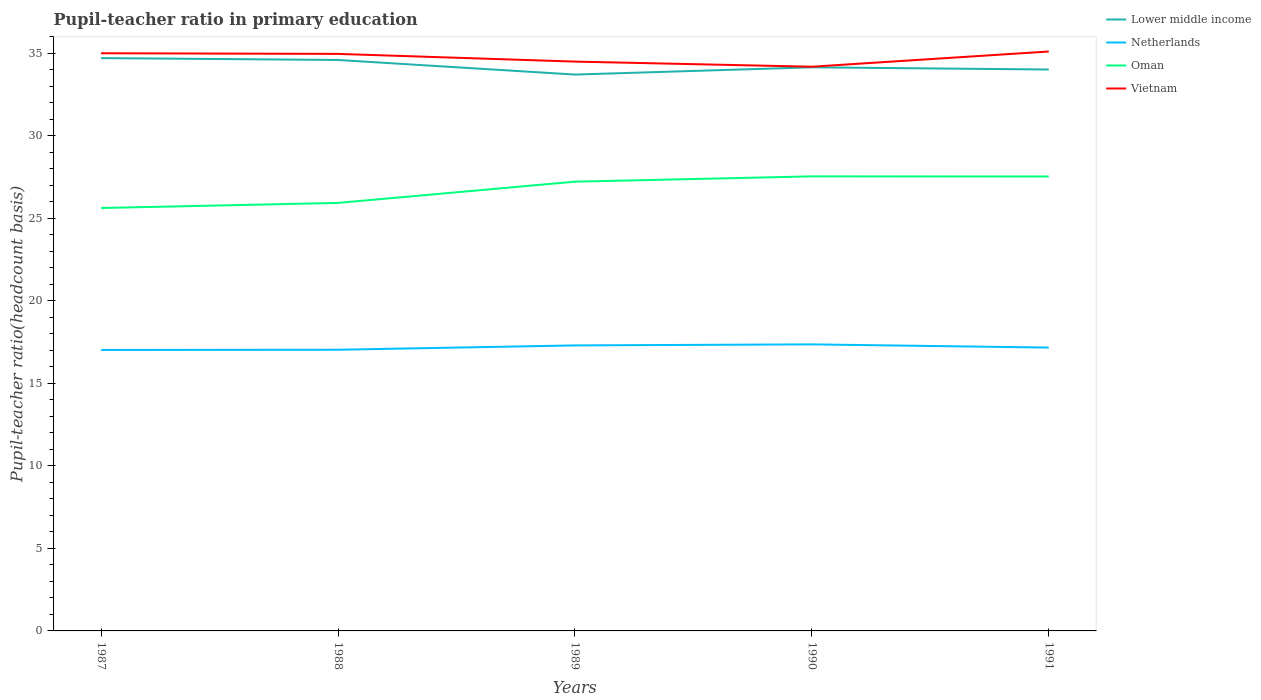Does the line corresponding to Netherlands intersect with the line corresponding to Vietnam?
Your answer should be very brief. No. Across all years, what is the maximum pupil-teacher ratio in primary education in Netherlands?
Ensure brevity in your answer.  17.02. In which year was the pupil-teacher ratio in primary education in Netherlands maximum?
Offer a terse response. 1987. What is the total pupil-teacher ratio in primary education in Netherlands in the graph?
Your answer should be very brief. 0.19. What is the difference between the highest and the second highest pupil-teacher ratio in primary education in Netherlands?
Give a very brief answer. 0.34. How many years are there in the graph?
Offer a terse response. 5. What is the difference between two consecutive major ticks on the Y-axis?
Provide a short and direct response. 5. How are the legend labels stacked?
Make the answer very short. Vertical. What is the title of the graph?
Your answer should be compact. Pupil-teacher ratio in primary education. Does "Zambia" appear as one of the legend labels in the graph?
Make the answer very short. No. What is the label or title of the Y-axis?
Give a very brief answer. Pupil-teacher ratio(headcount basis). What is the Pupil-teacher ratio(headcount basis) in Lower middle income in 1987?
Make the answer very short. 34.71. What is the Pupil-teacher ratio(headcount basis) of Netherlands in 1987?
Your answer should be very brief. 17.02. What is the Pupil-teacher ratio(headcount basis) of Oman in 1987?
Your answer should be compact. 25.63. What is the Pupil-teacher ratio(headcount basis) in Vietnam in 1987?
Your answer should be compact. 35. What is the Pupil-teacher ratio(headcount basis) in Lower middle income in 1988?
Offer a terse response. 34.6. What is the Pupil-teacher ratio(headcount basis) of Netherlands in 1988?
Your answer should be very brief. 17.04. What is the Pupil-teacher ratio(headcount basis) of Oman in 1988?
Your answer should be very brief. 25.93. What is the Pupil-teacher ratio(headcount basis) of Vietnam in 1988?
Ensure brevity in your answer.  34.96. What is the Pupil-teacher ratio(headcount basis) in Lower middle income in 1989?
Keep it short and to the point. 33.71. What is the Pupil-teacher ratio(headcount basis) of Netherlands in 1989?
Keep it short and to the point. 17.3. What is the Pupil-teacher ratio(headcount basis) in Oman in 1989?
Give a very brief answer. 27.22. What is the Pupil-teacher ratio(headcount basis) in Vietnam in 1989?
Ensure brevity in your answer.  34.5. What is the Pupil-teacher ratio(headcount basis) of Lower middle income in 1990?
Make the answer very short. 34.15. What is the Pupil-teacher ratio(headcount basis) of Netherlands in 1990?
Ensure brevity in your answer.  17.36. What is the Pupil-teacher ratio(headcount basis) in Oman in 1990?
Ensure brevity in your answer.  27.54. What is the Pupil-teacher ratio(headcount basis) in Vietnam in 1990?
Ensure brevity in your answer.  34.19. What is the Pupil-teacher ratio(headcount basis) of Lower middle income in 1991?
Make the answer very short. 34.02. What is the Pupil-teacher ratio(headcount basis) of Netherlands in 1991?
Ensure brevity in your answer.  17.17. What is the Pupil-teacher ratio(headcount basis) in Oman in 1991?
Your answer should be very brief. 27.54. What is the Pupil-teacher ratio(headcount basis) in Vietnam in 1991?
Give a very brief answer. 35.11. Across all years, what is the maximum Pupil-teacher ratio(headcount basis) in Lower middle income?
Your response must be concise. 34.71. Across all years, what is the maximum Pupil-teacher ratio(headcount basis) in Netherlands?
Provide a short and direct response. 17.36. Across all years, what is the maximum Pupil-teacher ratio(headcount basis) of Oman?
Ensure brevity in your answer.  27.54. Across all years, what is the maximum Pupil-teacher ratio(headcount basis) of Vietnam?
Provide a succinct answer. 35.11. Across all years, what is the minimum Pupil-teacher ratio(headcount basis) of Lower middle income?
Your answer should be compact. 33.71. Across all years, what is the minimum Pupil-teacher ratio(headcount basis) of Netherlands?
Keep it short and to the point. 17.02. Across all years, what is the minimum Pupil-teacher ratio(headcount basis) in Oman?
Make the answer very short. 25.63. Across all years, what is the minimum Pupil-teacher ratio(headcount basis) of Vietnam?
Offer a very short reply. 34.19. What is the total Pupil-teacher ratio(headcount basis) in Lower middle income in the graph?
Your answer should be compact. 171.19. What is the total Pupil-teacher ratio(headcount basis) of Netherlands in the graph?
Give a very brief answer. 85.9. What is the total Pupil-teacher ratio(headcount basis) of Oman in the graph?
Your answer should be compact. 133.86. What is the total Pupil-teacher ratio(headcount basis) in Vietnam in the graph?
Offer a very short reply. 173.77. What is the difference between the Pupil-teacher ratio(headcount basis) of Lower middle income in 1987 and that in 1988?
Your answer should be compact. 0.11. What is the difference between the Pupil-teacher ratio(headcount basis) of Netherlands in 1987 and that in 1988?
Keep it short and to the point. -0.01. What is the difference between the Pupil-teacher ratio(headcount basis) in Oman in 1987 and that in 1988?
Your answer should be compact. -0.31. What is the difference between the Pupil-teacher ratio(headcount basis) of Vietnam in 1987 and that in 1988?
Your response must be concise. 0.04. What is the difference between the Pupil-teacher ratio(headcount basis) in Netherlands in 1987 and that in 1989?
Provide a short and direct response. -0.28. What is the difference between the Pupil-teacher ratio(headcount basis) in Oman in 1987 and that in 1989?
Make the answer very short. -1.6. What is the difference between the Pupil-teacher ratio(headcount basis) of Vietnam in 1987 and that in 1989?
Your answer should be very brief. 0.51. What is the difference between the Pupil-teacher ratio(headcount basis) in Lower middle income in 1987 and that in 1990?
Give a very brief answer. 0.56. What is the difference between the Pupil-teacher ratio(headcount basis) in Netherlands in 1987 and that in 1990?
Offer a terse response. -0.34. What is the difference between the Pupil-teacher ratio(headcount basis) in Oman in 1987 and that in 1990?
Provide a short and direct response. -1.92. What is the difference between the Pupil-teacher ratio(headcount basis) of Vietnam in 1987 and that in 1990?
Make the answer very short. 0.82. What is the difference between the Pupil-teacher ratio(headcount basis) in Lower middle income in 1987 and that in 1991?
Keep it short and to the point. 0.69. What is the difference between the Pupil-teacher ratio(headcount basis) in Netherlands in 1987 and that in 1991?
Provide a short and direct response. -0.14. What is the difference between the Pupil-teacher ratio(headcount basis) of Oman in 1987 and that in 1991?
Make the answer very short. -1.91. What is the difference between the Pupil-teacher ratio(headcount basis) in Vietnam in 1987 and that in 1991?
Offer a very short reply. -0.11. What is the difference between the Pupil-teacher ratio(headcount basis) of Lower middle income in 1988 and that in 1989?
Ensure brevity in your answer.  0.88. What is the difference between the Pupil-teacher ratio(headcount basis) of Netherlands in 1988 and that in 1989?
Ensure brevity in your answer.  -0.26. What is the difference between the Pupil-teacher ratio(headcount basis) in Oman in 1988 and that in 1989?
Your answer should be compact. -1.29. What is the difference between the Pupil-teacher ratio(headcount basis) in Vietnam in 1988 and that in 1989?
Give a very brief answer. 0.47. What is the difference between the Pupil-teacher ratio(headcount basis) in Lower middle income in 1988 and that in 1990?
Ensure brevity in your answer.  0.44. What is the difference between the Pupil-teacher ratio(headcount basis) of Netherlands in 1988 and that in 1990?
Offer a very short reply. -0.32. What is the difference between the Pupil-teacher ratio(headcount basis) of Oman in 1988 and that in 1990?
Your answer should be very brief. -1.61. What is the difference between the Pupil-teacher ratio(headcount basis) in Vietnam in 1988 and that in 1990?
Offer a very short reply. 0.78. What is the difference between the Pupil-teacher ratio(headcount basis) in Lower middle income in 1988 and that in 1991?
Provide a short and direct response. 0.58. What is the difference between the Pupil-teacher ratio(headcount basis) in Netherlands in 1988 and that in 1991?
Your answer should be compact. -0.13. What is the difference between the Pupil-teacher ratio(headcount basis) in Oman in 1988 and that in 1991?
Your answer should be very brief. -1.6. What is the difference between the Pupil-teacher ratio(headcount basis) in Vietnam in 1988 and that in 1991?
Your response must be concise. -0.15. What is the difference between the Pupil-teacher ratio(headcount basis) in Lower middle income in 1989 and that in 1990?
Provide a succinct answer. -0.44. What is the difference between the Pupil-teacher ratio(headcount basis) in Netherlands in 1989 and that in 1990?
Give a very brief answer. -0.06. What is the difference between the Pupil-teacher ratio(headcount basis) of Oman in 1989 and that in 1990?
Make the answer very short. -0.32. What is the difference between the Pupil-teacher ratio(headcount basis) of Vietnam in 1989 and that in 1990?
Give a very brief answer. 0.31. What is the difference between the Pupil-teacher ratio(headcount basis) in Lower middle income in 1989 and that in 1991?
Offer a very short reply. -0.31. What is the difference between the Pupil-teacher ratio(headcount basis) of Netherlands in 1989 and that in 1991?
Your answer should be compact. 0.13. What is the difference between the Pupil-teacher ratio(headcount basis) of Oman in 1989 and that in 1991?
Your response must be concise. -0.31. What is the difference between the Pupil-teacher ratio(headcount basis) in Vietnam in 1989 and that in 1991?
Provide a succinct answer. -0.61. What is the difference between the Pupil-teacher ratio(headcount basis) in Lower middle income in 1990 and that in 1991?
Make the answer very short. 0.13. What is the difference between the Pupil-teacher ratio(headcount basis) in Netherlands in 1990 and that in 1991?
Offer a very short reply. 0.19. What is the difference between the Pupil-teacher ratio(headcount basis) of Oman in 1990 and that in 1991?
Offer a terse response. 0.01. What is the difference between the Pupil-teacher ratio(headcount basis) in Vietnam in 1990 and that in 1991?
Your response must be concise. -0.92. What is the difference between the Pupil-teacher ratio(headcount basis) of Lower middle income in 1987 and the Pupil-teacher ratio(headcount basis) of Netherlands in 1988?
Keep it short and to the point. 17.67. What is the difference between the Pupil-teacher ratio(headcount basis) of Lower middle income in 1987 and the Pupil-teacher ratio(headcount basis) of Oman in 1988?
Provide a short and direct response. 8.78. What is the difference between the Pupil-teacher ratio(headcount basis) of Lower middle income in 1987 and the Pupil-teacher ratio(headcount basis) of Vietnam in 1988?
Your response must be concise. -0.25. What is the difference between the Pupil-teacher ratio(headcount basis) of Netherlands in 1987 and the Pupil-teacher ratio(headcount basis) of Oman in 1988?
Make the answer very short. -8.91. What is the difference between the Pupil-teacher ratio(headcount basis) in Netherlands in 1987 and the Pupil-teacher ratio(headcount basis) in Vietnam in 1988?
Make the answer very short. -17.94. What is the difference between the Pupil-teacher ratio(headcount basis) in Oman in 1987 and the Pupil-teacher ratio(headcount basis) in Vietnam in 1988?
Make the answer very short. -9.34. What is the difference between the Pupil-teacher ratio(headcount basis) in Lower middle income in 1987 and the Pupil-teacher ratio(headcount basis) in Netherlands in 1989?
Provide a short and direct response. 17.41. What is the difference between the Pupil-teacher ratio(headcount basis) of Lower middle income in 1987 and the Pupil-teacher ratio(headcount basis) of Oman in 1989?
Make the answer very short. 7.49. What is the difference between the Pupil-teacher ratio(headcount basis) in Lower middle income in 1987 and the Pupil-teacher ratio(headcount basis) in Vietnam in 1989?
Ensure brevity in your answer.  0.21. What is the difference between the Pupil-teacher ratio(headcount basis) of Netherlands in 1987 and the Pupil-teacher ratio(headcount basis) of Oman in 1989?
Your response must be concise. -10.2. What is the difference between the Pupil-teacher ratio(headcount basis) in Netherlands in 1987 and the Pupil-teacher ratio(headcount basis) in Vietnam in 1989?
Ensure brevity in your answer.  -17.47. What is the difference between the Pupil-teacher ratio(headcount basis) of Oman in 1987 and the Pupil-teacher ratio(headcount basis) of Vietnam in 1989?
Ensure brevity in your answer.  -8.87. What is the difference between the Pupil-teacher ratio(headcount basis) of Lower middle income in 1987 and the Pupil-teacher ratio(headcount basis) of Netherlands in 1990?
Your response must be concise. 17.35. What is the difference between the Pupil-teacher ratio(headcount basis) of Lower middle income in 1987 and the Pupil-teacher ratio(headcount basis) of Oman in 1990?
Your answer should be compact. 7.17. What is the difference between the Pupil-teacher ratio(headcount basis) of Lower middle income in 1987 and the Pupil-teacher ratio(headcount basis) of Vietnam in 1990?
Provide a succinct answer. 0.52. What is the difference between the Pupil-teacher ratio(headcount basis) of Netherlands in 1987 and the Pupil-teacher ratio(headcount basis) of Oman in 1990?
Your response must be concise. -10.52. What is the difference between the Pupil-teacher ratio(headcount basis) in Netherlands in 1987 and the Pupil-teacher ratio(headcount basis) in Vietnam in 1990?
Provide a short and direct response. -17.16. What is the difference between the Pupil-teacher ratio(headcount basis) of Oman in 1987 and the Pupil-teacher ratio(headcount basis) of Vietnam in 1990?
Provide a succinct answer. -8.56. What is the difference between the Pupil-teacher ratio(headcount basis) in Lower middle income in 1987 and the Pupil-teacher ratio(headcount basis) in Netherlands in 1991?
Keep it short and to the point. 17.54. What is the difference between the Pupil-teacher ratio(headcount basis) in Lower middle income in 1987 and the Pupil-teacher ratio(headcount basis) in Oman in 1991?
Provide a succinct answer. 7.18. What is the difference between the Pupil-teacher ratio(headcount basis) in Lower middle income in 1987 and the Pupil-teacher ratio(headcount basis) in Vietnam in 1991?
Keep it short and to the point. -0.4. What is the difference between the Pupil-teacher ratio(headcount basis) of Netherlands in 1987 and the Pupil-teacher ratio(headcount basis) of Oman in 1991?
Offer a terse response. -10.51. What is the difference between the Pupil-teacher ratio(headcount basis) of Netherlands in 1987 and the Pupil-teacher ratio(headcount basis) of Vietnam in 1991?
Keep it short and to the point. -18.09. What is the difference between the Pupil-teacher ratio(headcount basis) in Oman in 1987 and the Pupil-teacher ratio(headcount basis) in Vietnam in 1991?
Provide a succinct answer. -9.48. What is the difference between the Pupil-teacher ratio(headcount basis) in Lower middle income in 1988 and the Pupil-teacher ratio(headcount basis) in Netherlands in 1989?
Ensure brevity in your answer.  17.3. What is the difference between the Pupil-teacher ratio(headcount basis) of Lower middle income in 1988 and the Pupil-teacher ratio(headcount basis) of Oman in 1989?
Offer a terse response. 7.37. What is the difference between the Pupil-teacher ratio(headcount basis) in Lower middle income in 1988 and the Pupil-teacher ratio(headcount basis) in Vietnam in 1989?
Keep it short and to the point. 0.1. What is the difference between the Pupil-teacher ratio(headcount basis) of Netherlands in 1988 and the Pupil-teacher ratio(headcount basis) of Oman in 1989?
Give a very brief answer. -10.18. What is the difference between the Pupil-teacher ratio(headcount basis) of Netherlands in 1988 and the Pupil-teacher ratio(headcount basis) of Vietnam in 1989?
Ensure brevity in your answer.  -17.46. What is the difference between the Pupil-teacher ratio(headcount basis) of Oman in 1988 and the Pupil-teacher ratio(headcount basis) of Vietnam in 1989?
Keep it short and to the point. -8.56. What is the difference between the Pupil-teacher ratio(headcount basis) in Lower middle income in 1988 and the Pupil-teacher ratio(headcount basis) in Netherlands in 1990?
Provide a short and direct response. 17.23. What is the difference between the Pupil-teacher ratio(headcount basis) in Lower middle income in 1988 and the Pupil-teacher ratio(headcount basis) in Oman in 1990?
Your answer should be compact. 7.05. What is the difference between the Pupil-teacher ratio(headcount basis) in Lower middle income in 1988 and the Pupil-teacher ratio(headcount basis) in Vietnam in 1990?
Provide a succinct answer. 0.41. What is the difference between the Pupil-teacher ratio(headcount basis) of Netherlands in 1988 and the Pupil-teacher ratio(headcount basis) of Oman in 1990?
Offer a terse response. -10.51. What is the difference between the Pupil-teacher ratio(headcount basis) of Netherlands in 1988 and the Pupil-teacher ratio(headcount basis) of Vietnam in 1990?
Offer a very short reply. -17.15. What is the difference between the Pupil-teacher ratio(headcount basis) in Oman in 1988 and the Pupil-teacher ratio(headcount basis) in Vietnam in 1990?
Give a very brief answer. -8.25. What is the difference between the Pupil-teacher ratio(headcount basis) of Lower middle income in 1988 and the Pupil-teacher ratio(headcount basis) of Netherlands in 1991?
Make the answer very short. 17.43. What is the difference between the Pupil-teacher ratio(headcount basis) in Lower middle income in 1988 and the Pupil-teacher ratio(headcount basis) in Oman in 1991?
Provide a succinct answer. 7.06. What is the difference between the Pupil-teacher ratio(headcount basis) of Lower middle income in 1988 and the Pupil-teacher ratio(headcount basis) of Vietnam in 1991?
Keep it short and to the point. -0.51. What is the difference between the Pupil-teacher ratio(headcount basis) of Netherlands in 1988 and the Pupil-teacher ratio(headcount basis) of Oman in 1991?
Give a very brief answer. -10.5. What is the difference between the Pupil-teacher ratio(headcount basis) in Netherlands in 1988 and the Pupil-teacher ratio(headcount basis) in Vietnam in 1991?
Provide a short and direct response. -18.07. What is the difference between the Pupil-teacher ratio(headcount basis) of Oman in 1988 and the Pupil-teacher ratio(headcount basis) of Vietnam in 1991?
Provide a succinct answer. -9.18. What is the difference between the Pupil-teacher ratio(headcount basis) of Lower middle income in 1989 and the Pupil-teacher ratio(headcount basis) of Netherlands in 1990?
Your response must be concise. 16.35. What is the difference between the Pupil-teacher ratio(headcount basis) in Lower middle income in 1989 and the Pupil-teacher ratio(headcount basis) in Oman in 1990?
Your answer should be compact. 6.17. What is the difference between the Pupil-teacher ratio(headcount basis) of Lower middle income in 1989 and the Pupil-teacher ratio(headcount basis) of Vietnam in 1990?
Provide a succinct answer. -0.48. What is the difference between the Pupil-teacher ratio(headcount basis) in Netherlands in 1989 and the Pupil-teacher ratio(headcount basis) in Oman in 1990?
Provide a succinct answer. -10.24. What is the difference between the Pupil-teacher ratio(headcount basis) of Netherlands in 1989 and the Pupil-teacher ratio(headcount basis) of Vietnam in 1990?
Your answer should be compact. -16.89. What is the difference between the Pupil-teacher ratio(headcount basis) in Oman in 1989 and the Pupil-teacher ratio(headcount basis) in Vietnam in 1990?
Keep it short and to the point. -6.97. What is the difference between the Pupil-teacher ratio(headcount basis) in Lower middle income in 1989 and the Pupil-teacher ratio(headcount basis) in Netherlands in 1991?
Offer a very short reply. 16.54. What is the difference between the Pupil-teacher ratio(headcount basis) in Lower middle income in 1989 and the Pupil-teacher ratio(headcount basis) in Oman in 1991?
Offer a very short reply. 6.18. What is the difference between the Pupil-teacher ratio(headcount basis) of Lower middle income in 1989 and the Pupil-teacher ratio(headcount basis) of Vietnam in 1991?
Offer a terse response. -1.4. What is the difference between the Pupil-teacher ratio(headcount basis) of Netherlands in 1989 and the Pupil-teacher ratio(headcount basis) of Oman in 1991?
Give a very brief answer. -10.23. What is the difference between the Pupil-teacher ratio(headcount basis) of Netherlands in 1989 and the Pupil-teacher ratio(headcount basis) of Vietnam in 1991?
Your answer should be compact. -17.81. What is the difference between the Pupil-teacher ratio(headcount basis) in Oman in 1989 and the Pupil-teacher ratio(headcount basis) in Vietnam in 1991?
Offer a terse response. -7.89. What is the difference between the Pupil-teacher ratio(headcount basis) in Lower middle income in 1990 and the Pupil-teacher ratio(headcount basis) in Netherlands in 1991?
Provide a succinct answer. 16.98. What is the difference between the Pupil-teacher ratio(headcount basis) in Lower middle income in 1990 and the Pupil-teacher ratio(headcount basis) in Oman in 1991?
Give a very brief answer. 6.62. What is the difference between the Pupil-teacher ratio(headcount basis) of Lower middle income in 1990 and the Pupil-teacher ratio(headcount basis) of Vietnam in 1991?
Offer a very short reply. -0.96. What is the difference between the Pupil-teacher ratio(headcount basis) in Netherlands in 1990 and the Pupil-teacher ratio(headcount basis) in Oman in 1991?
Provide a succinct answer. -10.17. What is the difference between the Pupil-teacher ratio(headcount basis) in Netherlands in 1990 and the Pupil-teacher ratio(headcount basis) in Vietnam in 1991?
Provide a succinct answer. -17.75. What is the difference between the Pupil-teacher ratio(headcount basis) in Oman in 1990 and the Pupil-teacher ratio(headcount basis) in Vietnam in 1991?
Ensure brevity in your answer.  -7.57. What is the average Pupil-teacher ratio(headcount basis) in Lower middle income per year?
Keep it short and to the point. 34.24. What is the average Pupil-teacher ratio(headcount basis) of Netherlands per year?
Give a very brief answer. 17.18. What is the average Pupil-teacher ratio(headcount basis) in Oman per year?
Your answer should be very brief. 26.77. What is the average Pupil-teacher ratio(headcount basis) of Vietnam per year?
Your response must be concise. 34.75. In the year 1987, what is the difference between the Pupil-teacher ratio(headcount basis) of Lower middle income and Pupil-teacher ratio(headcount basis) of Netherlands?
Offer a terse response. 17.69. In the year 1987, what is the difference between the Pupil-teacher ratio(headcount basis) in Lower middle income and Pupil-teacher ratio(headcount basis) in Oman?
Your response must be concise. 9.08. In the year 1987, what is the difference between the Pupil-teacher ratio(headcount basis) in Lower middle income and Pupil-teacher ratio(headcount basis) in Vietnam?
Offer a very short reply. -0.29. In the year 1987, what is the difference between the Pupil-teacher ratio(headcount basis) of Netherlands and Pupil-teacher ratio(headcount basis) of Oman?
Provide a succinct answer. -8.6. In the year 1987, what is the difference between the Pupil-teacher ratio(headcount basis) of Netherlands and Pupil-teacher ratio(headcount basis) of Vietnam?
Your answer should be very brief. -17.98. In the year 1987, what is the difference between the Pupil-teacher ratio(headcount basis) of Oman and Pupil-teacher ratio(headcount basis) of Vietnam?
Make the answer very short. -9.38. In the year 1988, what is the difference between the Pupil-teacher ratio(headcount basis) in Lower middle income and Pupil-teacher ratio(headcount basis) in Netherlands?
Offer a terse response. 17.56. In the year 1988, what is the difference between the Pupil-teacher ratio(headcount basis) of Lower middle income and Pupil-teacher ratio(headcount basis) of Oman?
Your answer should be compact. 8.66. In the year 1988, what is the difference between the Pupil-teacher ratio(headcount basis) of Lower middle income and Pupil-teacher ratio(headcount basis) of Vietnam?
Make the answer very short. -0.37. In the year 1988, what is the difference between the Pupil-teacher ratio(headcount basis) in Netherlands and Pupil-teacher ratio(headcount basis) in Oman?
Offer a terse response. -8.9. In the year 1988, what is the difference between the Pupil-teacher ratio(headcount basis) of Netherlands and Pupil-teacher ratio(headcount basis) of Vietnam?
Offer a terse response. -17.93. In the year 1988, what is the difference between the Pupil-teacher ratio(headcount basis) in Oman and Pupil-teacher ratio(headcount basis) in Vietnam?
Keep it short and to the point. -9.03. In the year 1989, what is the difference between the Pupil-teacher ratio(headcount basis) of Lower middle income and Pupil-teacher ratio(headcount basis) of Netherlands?
Provide a succinct answer. 16.41. In the year 1989, what is the difference between the Pupil-teacher ratio(headcount basis) in Lower middle income and Pupil-teacher ratio(headcount basis) in Oman?
Keep it short and to the point. 6.49. In the year 1989, what is the difference between the Pupil-teacher ratio(headcount basis) of Lower middle income and Pupil-teacher ratio(headcount basis) of Vietnam?
Offer a terse response. -0.79. In the year 1989, what is the difference between the Pupil-teacher ratio(headcount basis) in Netherlands and Pupil-teacher ratio(headcount basis) in Oman?
Keep it short and to the point. -9.92. In the year 1989, what is the difference between the Pupil-teacher ratio(headcount basis) in Netherlands and Pupil-teacher ratio(headcount basis) in Vietnam?
Your answer should be compact. -17.2. In the year 1989, what is the difference between the Pupil-teacher ratio(headcount basis) of Oman and Pupil-teacher ratio(headcount basis) of Vietnam?
Offer a terse response. -7.28. In the year 1990, what is the difference between the Pupil-teacher ratio(headcount basis) in Lower middle income and Pupil-teacher ratio(headcount basis) in Netherlands?
Your answer should be very brief. 16.79. In the year 1990, what is the difference between the Pupil-teacher ratio(headcount basis) in Lower middle income and Pupil-teacher ratio(headcount basis) in Oman?
Provide a short and direct response. 6.61. In the year 1990, what is the difference between the Pupil-teacher ratio(headcount basis) of Lower middle income and Pupil-teacher ratio(headcount basis) of Vietnam?
Provide a succinct answer. -0.04. In the year 1990, what is the difference between the Pupil-teacher ratio(headcount basis) in Netherlands and Pupil-teacher ratio(headcount basis) in Oman?
Provide a short and direct response. -10.18. In the year 1990, what is the difference between the Pupil-teacher ratio(headcount basis) of Netherlands and Pupil-teacher ratio(headcount basis) of Vietnam?
Offer a very short reply. -16.82. In the year 1990, what is the difference between the Pupil-teacher ratio(headcount basis) in Oman and Pupil-teacher ratio(headcount basis) in Vietnam?
Offer a terse response. -6.64. In the year 1991, what is the difference between the Pupil-teacher ratio(headcount basis) of Lower middle income and Pupil-teacher ratio(headcount basis) of Netherlands?
Provide a succinct answer. 16.85. In the year 1991, what is the difference between the Pupil-teacher ratio(headcount basis) in Lower middle income and Pupil-teacher ratio(headcount basis) in Oman?
Give a very brief answer. 6.48. In the year 1991, what is the difference between the Pupil-teacher ratio(headcount basis) in Lower middle income and Pupil-teacher ratio(headcount basis) in Vietnam?
Offer a terse response. -1.09. In the year 1991, what is the difference between the Pupil-teacher ratio(headcount basis) in Netherlands and Pupil-teacher ratio(headcount basis) in Oman?
Provide a succinct answer. -10.37. In the year 1991, what is the difference between the Pupil-teacher ratio(headcount basis) of Netherlands and Pupil-teacher ratio(headcount basis) of Vietnam?
Your response must be concise. -17.94. In the year 1991, what is the difference between the Pupil-teacher ratio(headcount basis) in Oman and Pupil-teacher ratio(headcount basis) in Vietnam?
Keep it short and to the point. -7.58. What is the ratio of the Pupil-teacher ratio(headcount basis) in Vietnam in 1987 to that in 1988?
Your response must be concise. 1. What is the ratio of the Pupil-teacher ratio(headcount basis) of Lower middle income in 1987 to that in 1989?
Make the answer very short. 1.03. What is the ratio of the Pupil-teacher ratio(headcount basis) in Oman in 1987 to that in 1989?
Provide a succinct answer. 0.94. What is the ratio of the Pupil-teacher ratio(headcount basis) of Vietnam in 1987 to that in 1989?
Make the answer very short. 1.01. What is the ratio of the Pupil-teacher ratio(headcount basis) in Lower middle income in 1987 to that in 1990?
Offer a terse response. 1.02. What is the ratio of the Pupil-teacher ratio(headcount basis) in Netherlands in 1987 to that in 1990?
Provide a short and direct response. 0.98. What is the ratio of the Pupil-teacher ratio(headcount basis) of Oman in 1987 to that in 1990?
Give a very brief answer. 0.93. What is the ratio of the Pupil-teacher ratio(headcount basis) of Vietnam in 1987 to that in 1990?
Offer a very short reply. 1.02. What is the ratio of the Pupil-teacher ratio(headcount basis) of Lower middle income in 1987 to that in 1991?
Keep it short and to the point. 1.02. What is the ratio of the Pupil-teacher ratio(headcount basis) of Oman in 1987 to that in 1991?
Provide a short and direct response. 0.93. What is the ratio of the Pupil-teacher ratio(headcount basis) of Vietnam in 1987 to that in 1991?
Your answer should be very brief. 1. What is the ratio of the Pupil-teacher ratio(headcount basis) in Lower middle income in 1988 to that in 1989?
Your answer should be very brief. 1.03. What is the ratio of the Pupil-teacher ratio(headcount basis) of Netherlands in 1988 to that in 1989?
Offer a very short reply. 0.98. What is the ratio of the Pupil-teacher ratio(headcount basis) of Oman in 1988 to that in 1989?
Your answer should be very brief. 0.95. What is the ratio of the Pupil-teacher ratio(headcount basis) of Vietnam in 1988 to that in 1989?
Ensure brevity in your answer.  1.01. What is the ratio of the Pupil-teacher ratio(headcount basis) in Netherlands in 1988 to that in 1990?
Your response must be concise. 0.98. What is the ratio of the Pupil-teacher ratio(headcount basis) of Oman in 1988 to that in 1990?
Ensure brevity in your answer.  0.94. What is the ratio of the Pupil-teacher ratio(headcount basis) in Vietnam in 1988 to that in 1990?
Your answer should be very brief. 1.02. What is the ratio of the Pupil-teacher ratio(headcount basis) in Oman in 1988 to that in 1991?
Provide a short and direct response. 0.94. What is the ratio of the Pupil-teacher ratio(headcount basis) of Vietnam in 1988 to that in 1991?
Your response must be concise. 1. What is the ratio of the Pupil-teacher ratio(headcount basis) of Lower middle income in 1989 to that in 1990?
Offer a terse response. 0.99. What is the ratio of the Pupil-teacher ratio(headcount basis) in Netherlands in 1989 to that in 1990?
Your answer should be very brief. 1. What is the ratio of the Pupil-teacher ratio(headcount basis) in Oman in 1989 to that in 1990?
Offer a terse response. 0.99. What is the ratio of the Pupil-teacher ratio(headcount basis) of Vietnam in 1989 to that in 1990?
Ensure brevity in your answer.  1.01. What is the ratio of the Pupil-teacher ratio(headcount basis) in Netherlands in 1989 to that in 1991?
Your response must be concise. 1.01. What is the ratio of the Pupil-teacher ratio(headcount basis) in Oman in 1989 to that in 1991?
Give a very brief answer. 0.99. What is the ratio of the Pupil-teacher ratio(headcount basis) in Vietnam in 1989 to that in 1991?
Provide a succinct answer. 0.98. What is the ratio of the Pupil-teacher ratio(headcount basis) in Lower middle income in 1990 to that in 1991?
Your response must be concise. 1. What is the ratio of the Pupil-teacher ratio(headcount basis) of Netherlands in 1990 to that in 1991?
Make the answer very short. 1.01. What is the ratio of the Pupil-teacher ratio(headcount basis) in Oman in 1990 to that in 1991?
Provide a short and direct response. 1. What is the ratio of the Pupil-teacher ratio(headcount basis) of Vietnam in 1990 to that in 1991?
Your answer should be very brief. 0.97. What is the difference between the highest and the second highest Pupil-teacher ratio(headcount basis) in Lower middle income?
Offer a terse response. 0.11. What is the difference between the highest and the second highest Pupil-teacher ratio(headcount basis) in Netherlands?
Offer a very short reply. 0.06. What is the difference between the highest and the second highest Pupil-teacher ratio(headcount basis) in Oman?
Your answer should be compact. 0.01. What is the difference between the highest and the second highest Pupil-teacher ratio(headcount basis) in Vietnam?
Your response must be concise. 0.11. What is the difference between the highest and the lowest Pupil-teacher ratio(headcount basis) of Lower middle income?
Keep it short and to the point. 1. What is the difference between the highest and the lowest Pupil-teacher ratio(headcount basis) of Netherlands?
Your answer should be very brief. 0.34. What is the difference between the highest and the lowest Pupil-teacher ratio(headcount basis) in Oman?
Your answer should be compact. 1.92. What is the difference between the highest and the lowest Pupil-teacher ratio(headcount basis) in Vietnam?
Ensure brevity in your answer.  0.92. 